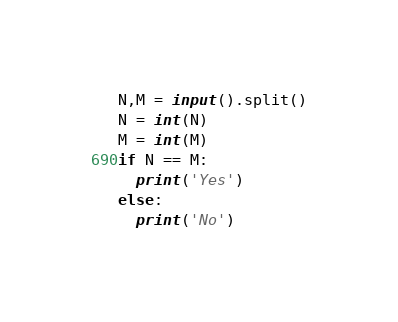Convert code to text. <code><loc_0><loc_0><loc_500><loc_500><_Python_>N,M = input().split()
N = int(N)
M = int(M)
if N == M:
  print('Yes')
else:
  print('No')</code> 